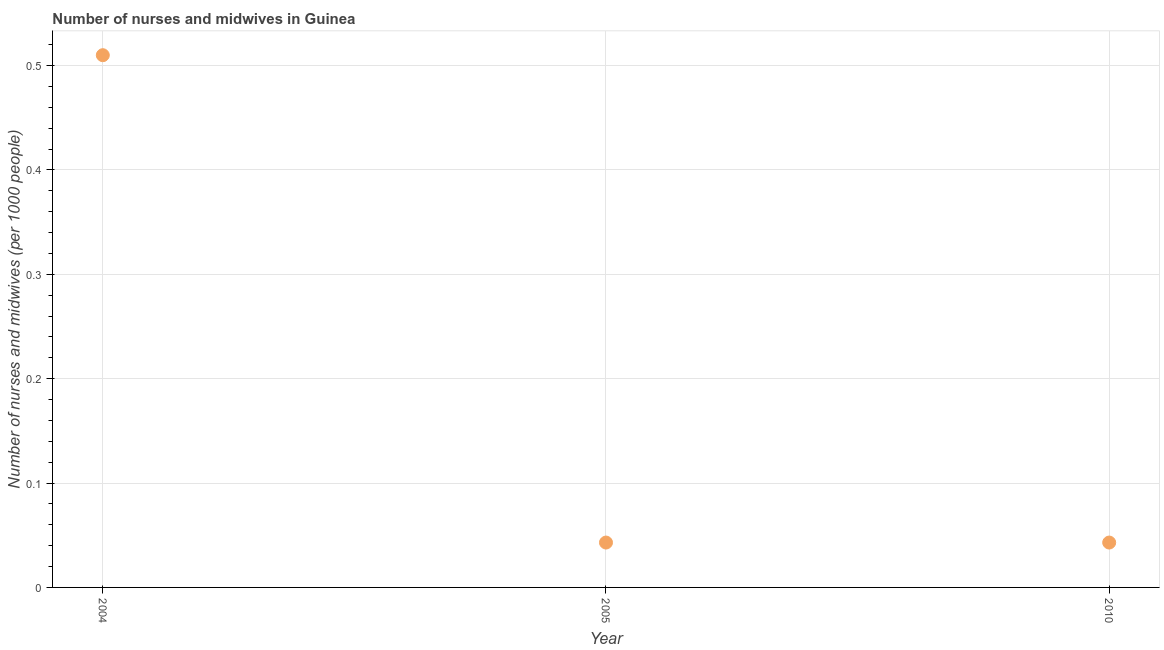What is the number of nurses and midwives in 2010?
Ensure brevity in your answer.  0.04. Across all years, what is the maximum number of nurses and midwives?
Your answer should be compact. 0.51. Across all years, what is the minimum number of nurses and midwives?
Your answer should be very brief. 0.04. In which year was the number of nurses and midwives maximum?
Provide a succinct answer. 2004. In which year was the number of nurses and midwives minimum?
Ensure brevity in your answer.  2005. What is the sum of the number of nurses and midwives?
Your answer should be compact. 0.6. What is the average number of nurses and midwives per year?
Provide a short and direct response. 0.2. What is the median number of nurses and midwives?
Keep it short and to the point. 0.04. Do a majority of the years between 2005 and 2010 (inclusive) have number of nurses and midwives greater than 0.12000000000000001 ?
Provide a succinct answer. No. What is the ratio of the number of nurses and midwives in 2005 to that in 2010?
Offer a terse response. 1. Is the number of nurses and midwives in 2004 less than that in 2010?
Keep it short and to the point. No. Is the difference between the number of nurses and midwives in 2004 and 2010 greater than the difference between any two years?
Offer a very short reply. Yes. What is the difference between the highest and the second highest number of nurses and midwives?
Provide a short and direct response. 0.47. What is the difference between the highest and the lowest number of nurses and midwives?
Offer a very short reply. 0.47. How many dotlines are there?
Keep it short and to the point. 1. What is the difference between two consecutive major ticks on the Y-axis?
Offer a very short reply. 0.1. Does the graph contain any zero values?
Offer a very short reply. No. Does the graph contain grids?
Provide a succinct answer. Yes. What is the title of the graph?
Provide a succinct answer. Number of nurses and midwives in Guinea. What is the label or title of the X-axis?
Keep it short and to the point. Year. What is the label or title of the Y-axis?
Offer a very short reply. Number of nurses and midwives (per 1000 people). What is the Number of nurses and midwives (per 1000 people) in 2004?
Provide a succinct answer. 0.51. What is the Number of nurses and midwives (per 1000 people) in 2005?
Your response must be concise. 0.04. What is the Number of nurses and midwives (per 1000 people) in 2010?
Offer a very short reply. 0.04. What is the difference between the Number of nurses and midwives (per 1000 people) in 2004 and 2005?
Keep it short and to the point. 0.47. What is the difference between the Number of nurses and midwives (per 1000 people) in 2004 and 2010?
Offer a terse response. 0.47. What is the ratio of the Number of nurses and midwives (per 1000 people) in 2004 to that in 2005?
Your answer should be compact. 11.86. What is the ratio of the Number of nurses and midwives (per 1000 people) in 2004 to that in 2010?
Make the answer very short. 11.86. 